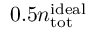Convert formula to latex. <formula><loc_0><loc_0><loc_500><loc_500>0 . 5 n _ { t o t } ^ { i d e a l }</formula> 